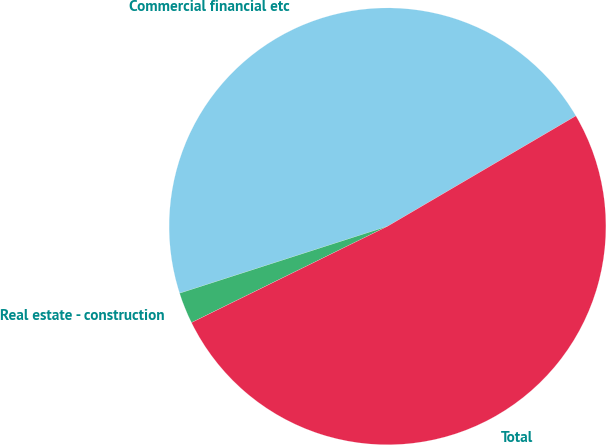Convert chart to OTSL. <chart><loc_0><loc_0><loc_500><loc_500><pie_chart><fcel>Commercial financial etc<fcel>Real estate - construction<fcel>Total<nl><fcel>46.52%<fcel>2.31%<fcel>51.17%<nl></chart> 